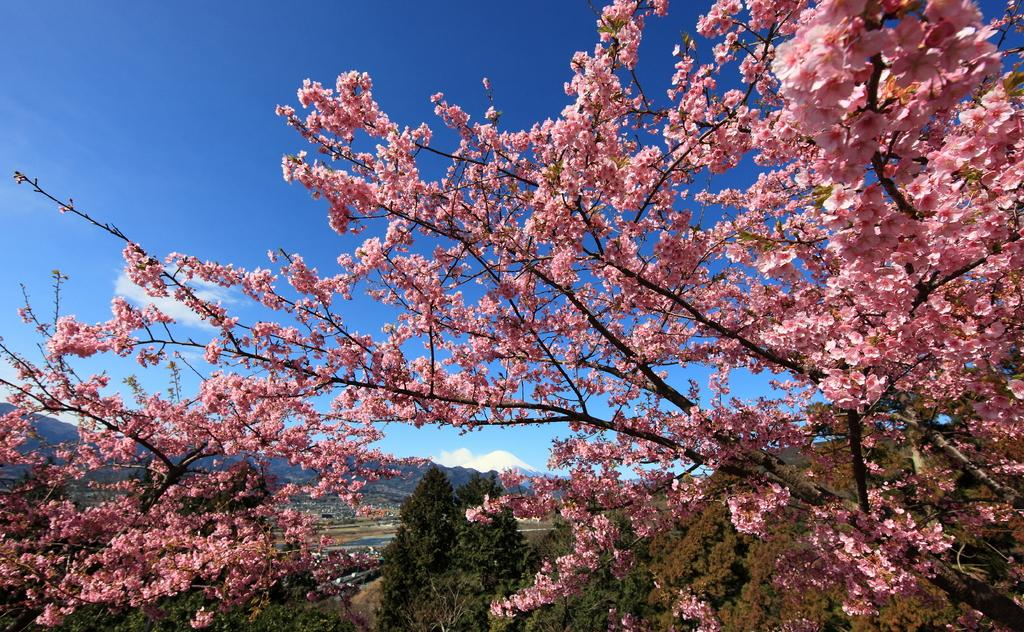What is on the branches of the tree in the image? There are flowers on the branches of a tree in the image. What can be seen in the background of the image? There are trees and mountains in the background of the image. How many pigs are lying on the sheet in the image? There are no pigs or sheets present in the image. 